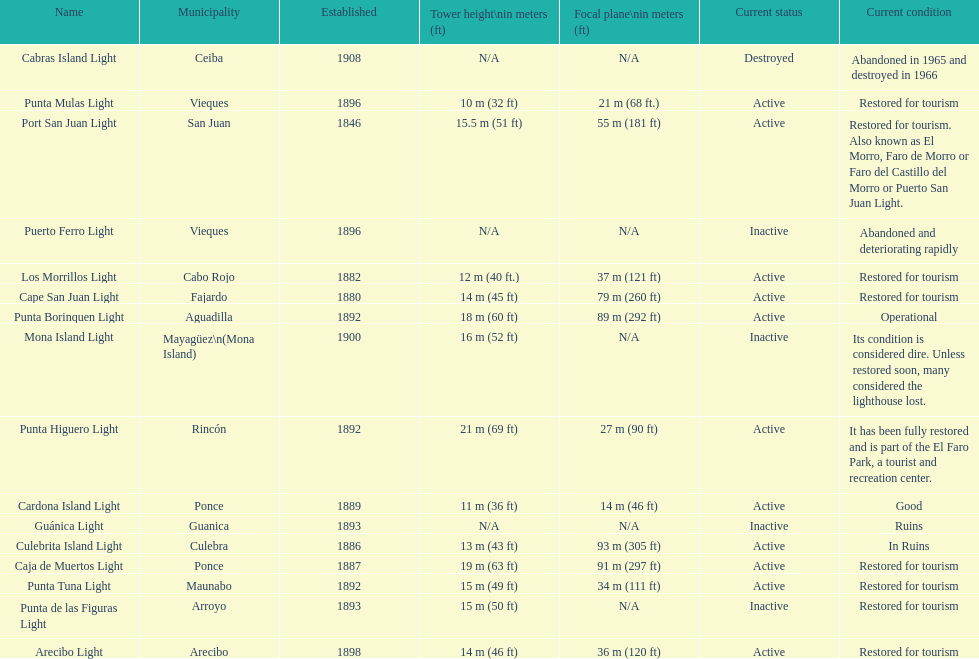What is the largest tower Punta Higuero Light. 